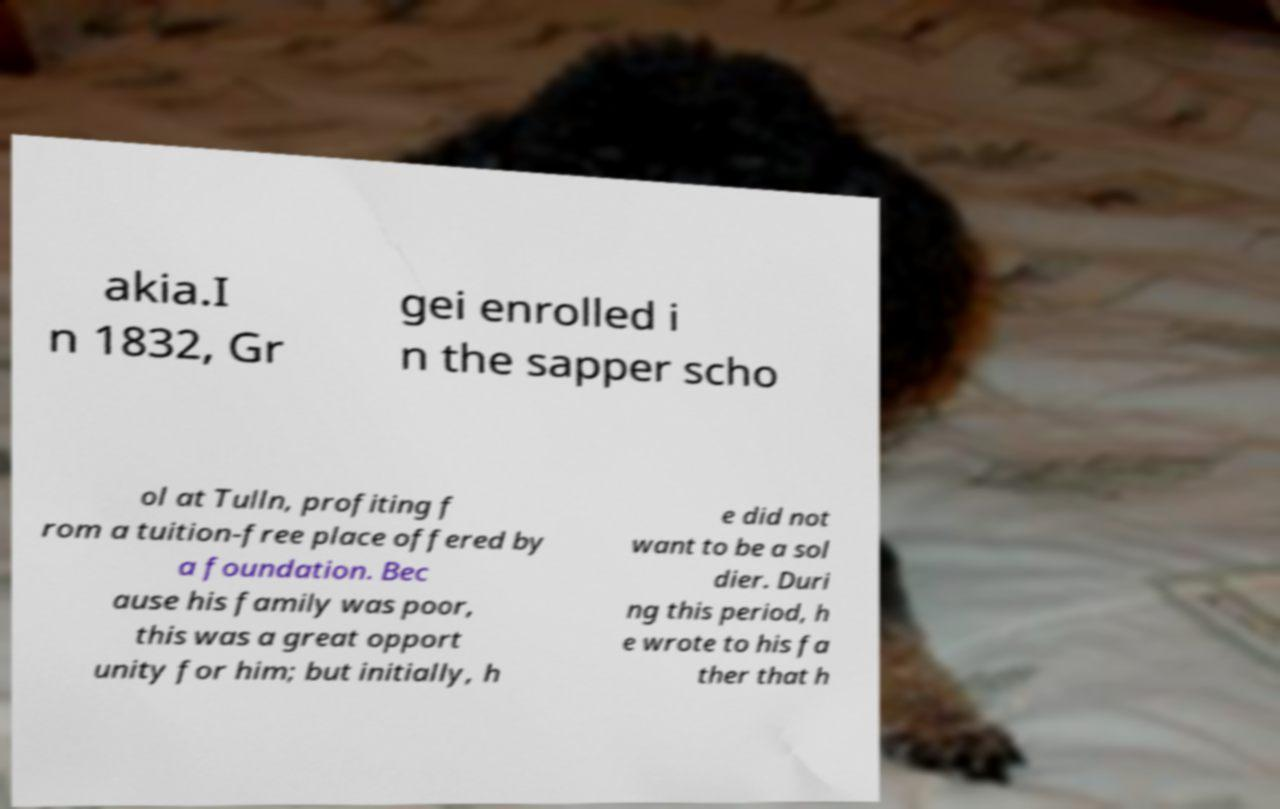I need the written content from this picture converted into text. Can you do that? akia.I n 1832, Gr gei enrolled i n the sapper scho ol at Tulln, profiting f rom a tuition-free place offered by a foundation. Bec ause his family was poor, this was a great opport unity for him; but initially, h e did not want to be a sol dier. Duri ng this period, h e wrote to his fa ther that h 